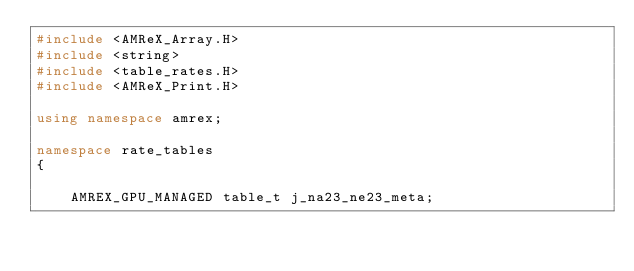<code> <loc_0><loc_0><loc_500><loc_500><_C++_>#include <AMReX_Array.H>
#include <string>
#include <table_rates.H>
#include <AMReX_Print.H>

using namespace amrex;

namespace rate_tables
{

    AMREX_GPU_MANAGED table_t j_na23_ne23_meta;</code> 